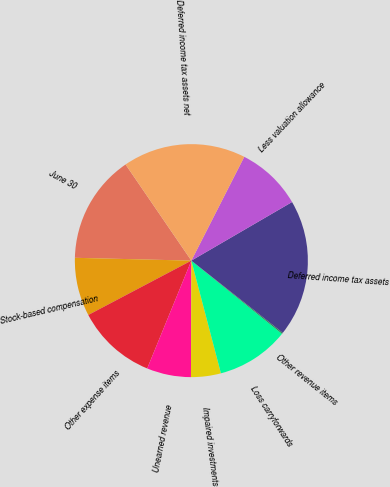Convert chart to OTSL. <chart><loc_0><loc_0><loc_500><loc_500><pie_chart><fcel>June 30<fcel>Stock-based compensation<fcel>Other expense items<fcel>Unearned revenue<fcel>Impaired investments<fcel>Loss carryforwards<fcel>Other revenue items<fcel>Deferred income tax assets<fcel>Less valuation allowance<fcel>Deferred income tax assets net<nl><fcel>15.06%<fcel>8.11%<fcel>11.09%<fcel>6.13%<fcel>4.14%<fcel>10.1%<fcel>0.17%<fcel>19.03%<fcel>9.11%<fcel>17.05%<nl></chart> 